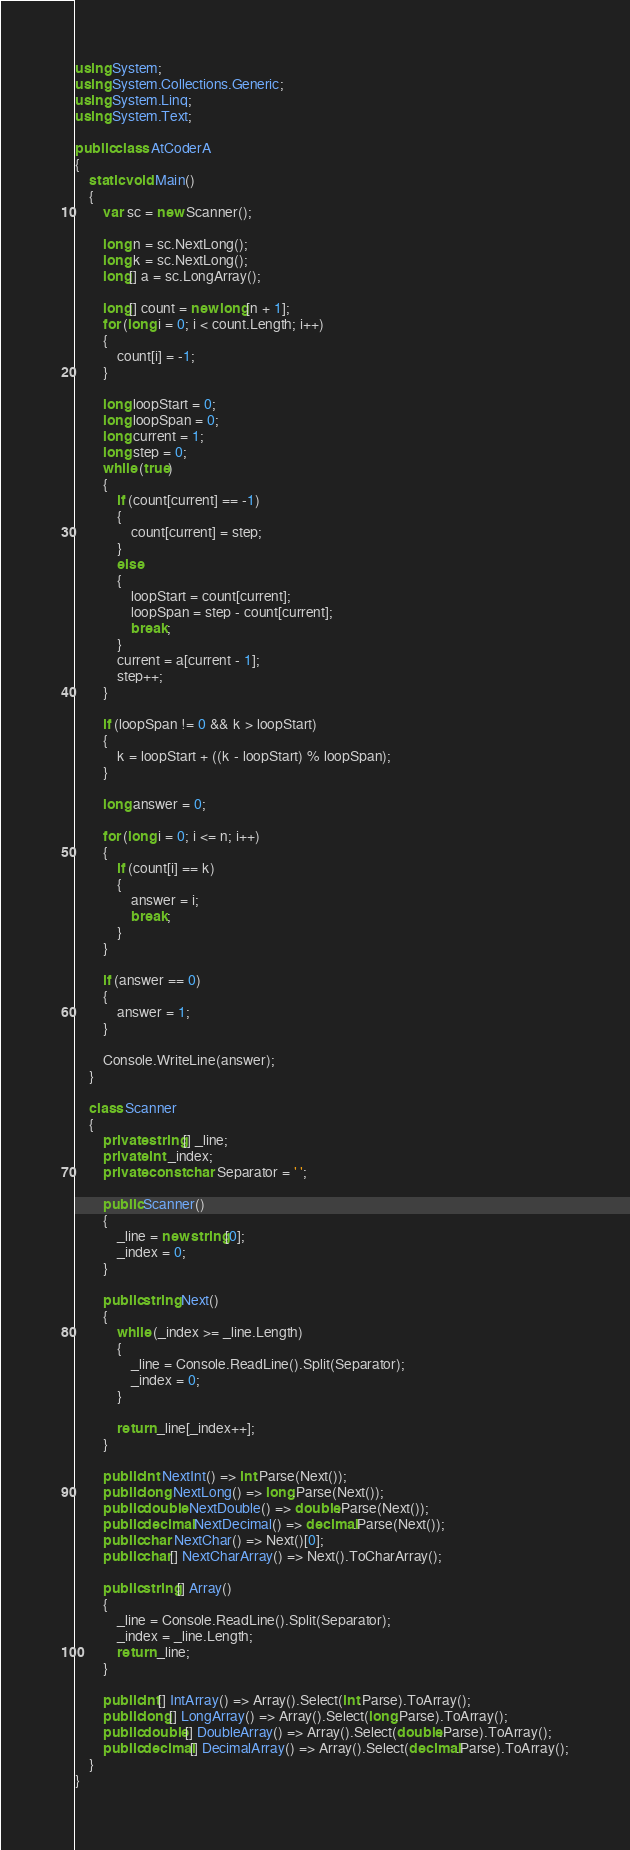<code> <loc_0><loc_0><loc_500><loc_500><_C#_>using System;
using System.Collections.Generic;
using System.Linq;
using System.Text;

public class AtCoderA
{
    static void Main()
    {
        var sc = new Scanner();

        long n = sc.NextLong();
        long k = sc.NextLong();
        long[] a = sc.LongArray();

        long[] count = new long[n + 1];
        for (long i = 0; i < count.Length; i++)
        {
            count[i] = -1;
        }

        long loopStart = 0;
        long loopSpan = 0;
        long current = 1;
        long step = 0;
        while (true)
        {
            if (count[current] == -1)
            {
                count[current] = step;
            }
            else
            {
                loopStart = count[current];
                loopSpan = step - count[current];
                break;
            }
            current = a[current - 1];
            step++;
        }

        if (loopSpan != 0 && k > loopStart)
        {
            k = loopStart + ((k - loopStart) % loopSpan);
        }

        long answer = 0;

        for (long i = 0; i <= n; i++)
        {
            if (count[i] == k)
            {
                answer = i;
                break;
            }
        }

        if (answer == 0)
        {
            answer = 1;
        }

        Console.WriteLine(answer);
    }

    class Scanner
    {
        private string[] _line;
        private int _index;
        private const char Separator = ' ';

        public Scanner()
        {
            _line = new string[0];
            _index = 0;
        }

        public string Next()
        {
            while (_index >= _line.Length)
            {
                _line = Console.ReadLine().Split(Separator);
                _index = 0;
            }

            return _line[_index++];
        }

        public int NextInt() => int.Parse(Next());
        public long NextLong() => long.Parse(Next());
        public double NextDouble() => double.Parse(Next());
        public decimal NextDecimal() => decimal.Parse(Next());
        public char NextChar() => Next()[0];
        public char[] NextCharArray() => Next().ToCharArray();

        public string[] Array()
        {
            _line = Console.ReadLine().Split(Separator);
            _index = _line.Length;
            return _line;
        }

        public int[] IntArray() => Array().Select(int.Parse).ToArray();
        public long[] LongArray() => Array().Select(long.Parse).ToArray();
        public double[] DoubleArray() => Array().Select(double.Parse).ToArray();
        public decimal[] DecimalArray() => Array().Select(decimal.Parse).ToArray();
    }
}</code> 